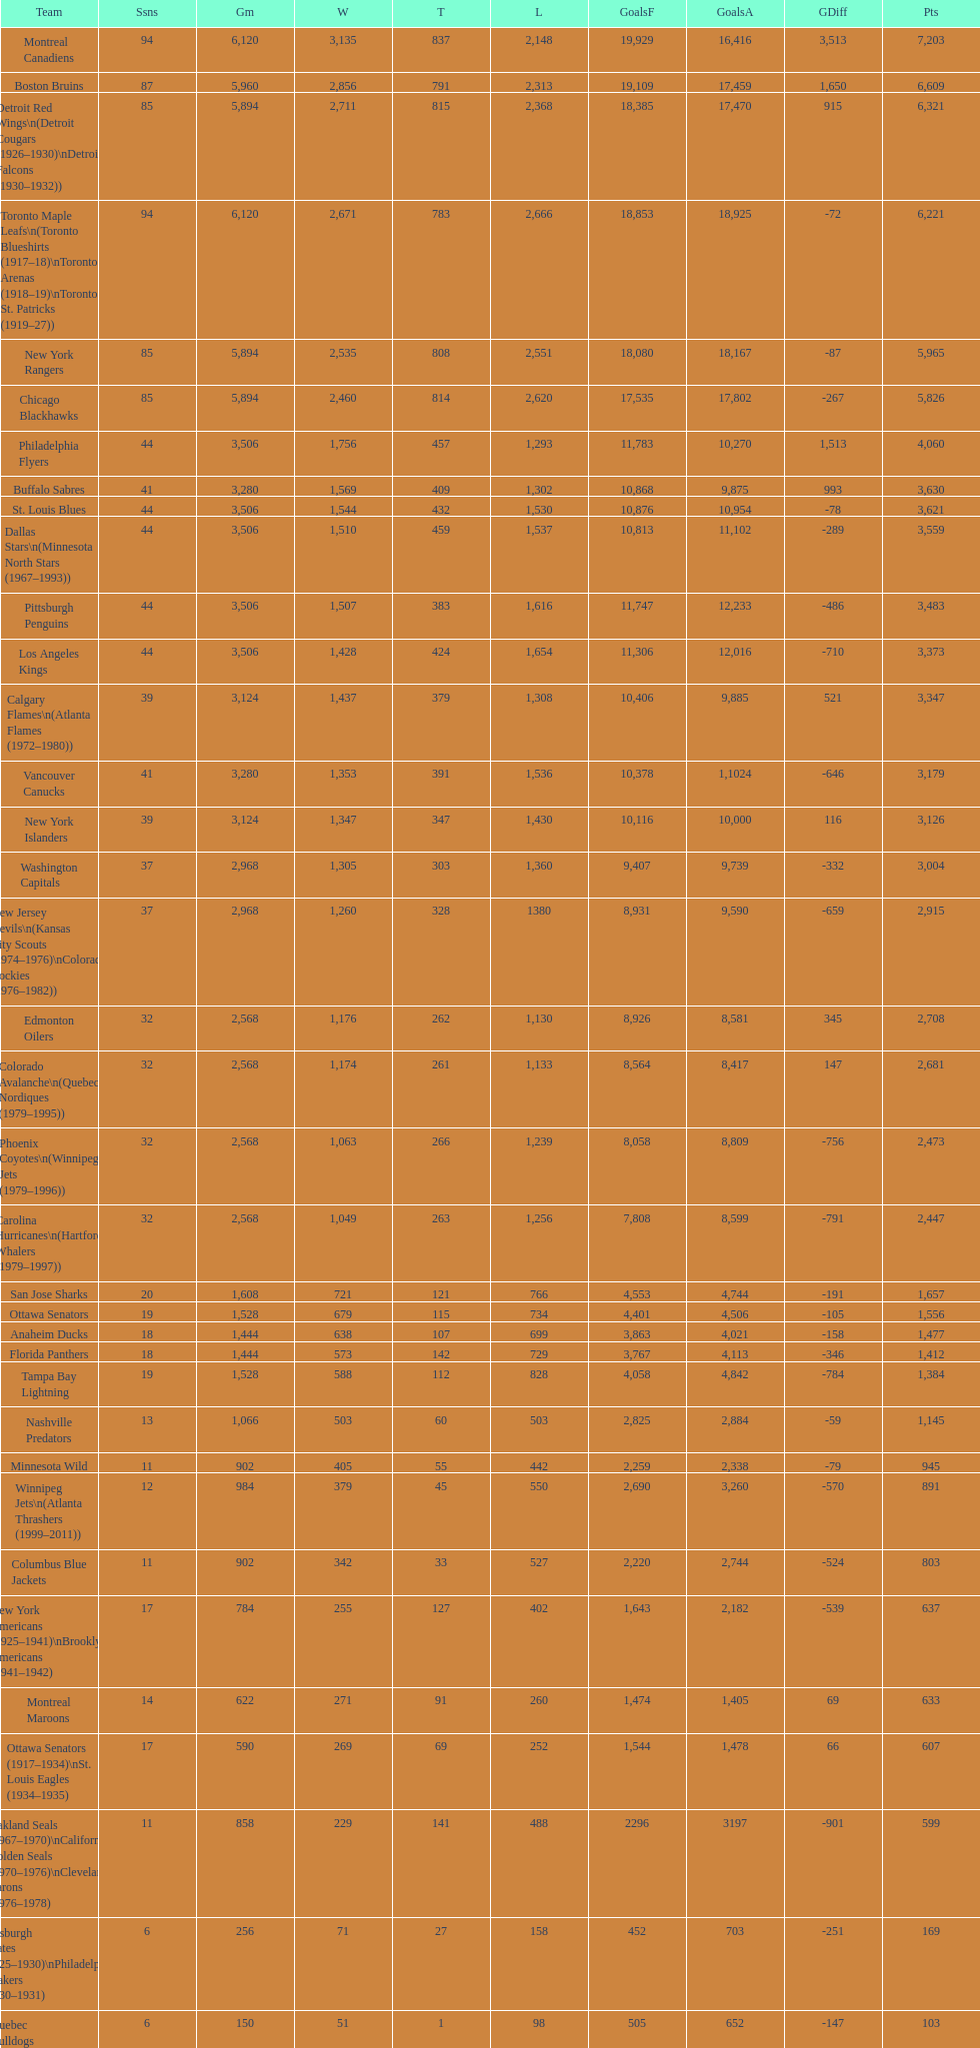Who is at the top of the list? Montreal Canadiens. 